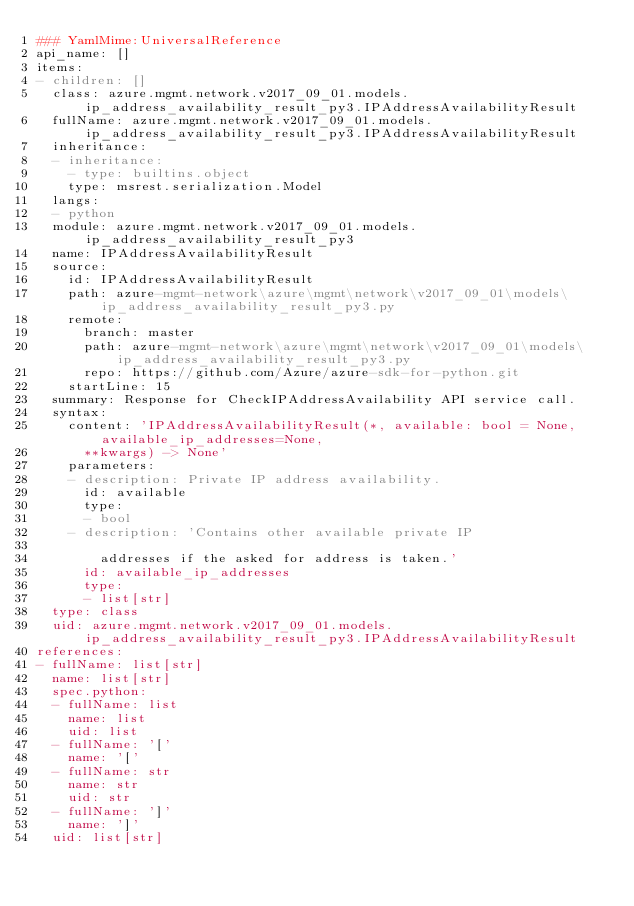Convert code to text. <code><loc_0><loc_0><loc_500><loc_500><_YAML_>### YamlMime:UniversalReference
api_name: []
items:
- children: []
  class: azure.mgmt.network.v2017_09_01.models.ip_address_availability_result_py3.IPAddressAvailabilityResult
  fullName: azure.mgmt.network.v2017_09_01.models.ip_address_availability_result_py3.IPAddressAvailabilityResult
  inheritance:
  - inheritance:
    - type: builtins.object
    type: msrest.serialization.Model
  langs:
  - python
  module: azure.mgmt.network.v2017_09_01.models.ip_address_availability_result_py3
  name: IPAddressAvailabilityResult
  source:
    id: IPAddressAvailabilityResult
    path: azure-mgmt-network\azure\mgmt\network\v2017_09_01\models\ip_address_availability_result_py3.py
    remote:
      branch: master
      path: azure-mgmt-network\azure\mgmt\network\v2017_09_01\models\ip_address_availability_result_py3.py
      repo: https://github.com/Azure/azure-sdk-for-python.git
    startLine: 15
  summary: Response for CheckIPAddressAvailability API service call.
  syntax:
    content: 'IPAddressAvailabilityResult(*, available: bool = None, available_ip_addresses=None,
      **kwargs) -> None'
    parameters:
    - description: Private IP address availability.
      id: available
      type:
      - bool
    - description: 'Contains other available private IP

        addresses if the asked for address is taken.'
      id: available_ip_addresses
      type:
      - list[str]
  type: class
  uid: azure.mgmt.network.v2017_09_01.models.ip_address_availability_result_py3.IPAddressAvailabilityResult
references:
- fullName: list[str]
  name: list[str]
  spec.python:
  - fullName: list
    name: list
    uid: list
  - fullName: '['
    name: '['
  - fullName: str
    name: str
    uid: str
  - fullName: ']'
    name: ']'
  uid: list[str]
</code> 